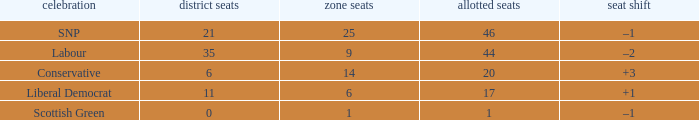What is the full number of Total Seats with a constituency seat number bigger than 0 with the Liberal Democrat party, and the Regional seat number is smaller than 6? None. 